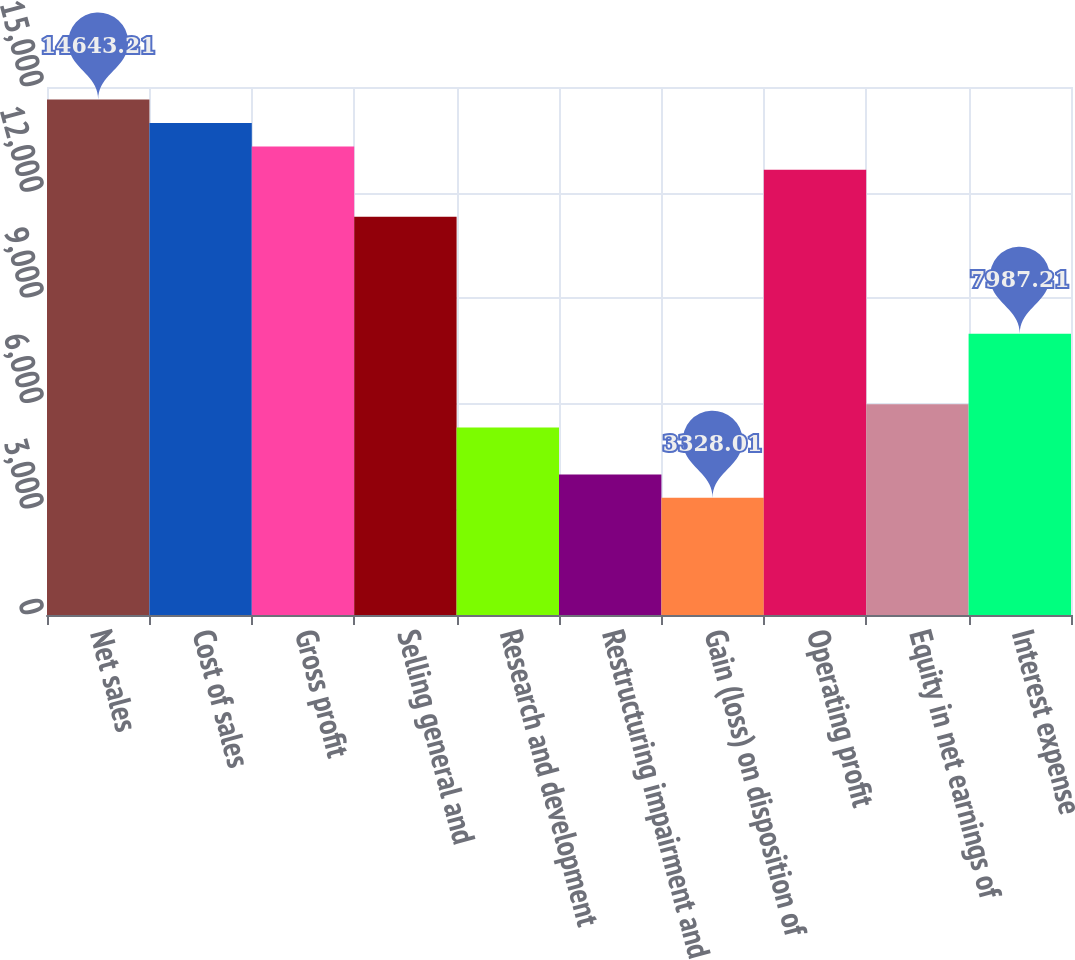Convert chart. <chart><loc_0><loc_0><loc_500><loc_500><bar_chart><fcel>Net sales<fcel>Cost of sales<fcel>Gross profit<fcel>Selling general and<fcel>Research and development<fcel>Restructuring impairment and<fcel>Gain (loss) on disposition of<fcel>Operating profit<fcel>Equity in net earnings of<fcel>Interest expense<nl><fcel>14643.2<fcel>13977.6<fcel>13312<fcel>11315.2<fcel>5324.81<fcel>3993.61<fcel>3328.01<fcel>12646.4<fcel>5990.41<fcel>7987.21<nl></chart> 